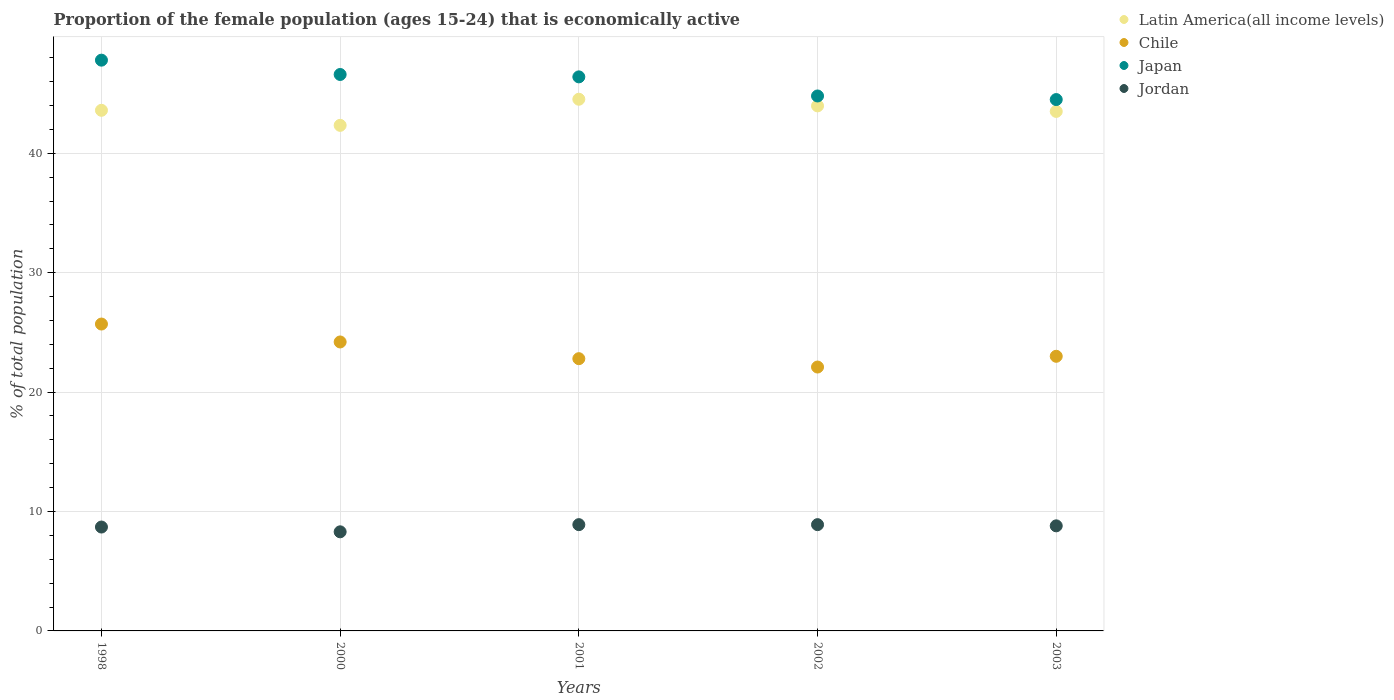How many different coloured dotlines are there?
Offer a very short reply. 4. Is the number of dotlines equal to the number of legend labels?
Make the answer very short. Yes. What is the proportion of the female population that is economically active in Latin America(all income levels) in 2002?
Offer a very short reply. 43.97. Across all years, what is the maximum proportion of the female population that is economically active in Latin America(all income levels)?
Your answer should be very brief. 44.53. Across all years, what is the minimum proportion of the female population that is economically active in Chile?
Your answer should be compact. 22.1. What is the total proportion of the female population that is economically active in Jordan in the graph?
Provide a short and direct response. 43.6. What is the difference between the proportion of the female population that is economically active in Japan in 1998 and that in 2000?
Offer a very short reply. 1.2. What is the difference between the proportion of the female population that is economically active in Japan in 2003 and the proportion of the female population that is economically active in Jordan in 2000?
Give a very brief answer. 36.2. What is the average proportion of the female population that is economically active in Japan per year?
Your response must be concise. 46.02. In the year 2001, what is the difference between the proportion of the female population that is economically active in Jordan and proportion of the female population that is economically active in Chile?
Your answer should be very brief. -13.9. What is the ratio of the proportion of the female population that is economically active in Latin America(all income levels) in 1998 to that in 2001?
Offer a very short reply. 0.98. Is the difference between the proportion of the female population that is economically active in Jordan in 1998 and 2003 greater than the difference between the proportion of the female population that is economically active in Chile in 1998 and 2003?
Offer a terse response. No. What is the difference between the highest and the second highest proportion of the female population that is economically active in Jordan?
Provide a short and direct response. 0. What is the difference between the highest and the lowest proportion of the female population that is economically active in Jordan?
Offer a very short reply. 0.6. In how many years, is the proportion of the female population that is economically active in Chile greater than the average proportion of the female population that is economically active in Chile taken over all years?
Offer a very short reply. 2. Is the sum of the proportion of the female population that is economically active in Chile in 2000 and 2003 greater than the maximum proportion of the female population that is economically active in Jordan across all years?
Your answer should be very brief. Yes. Does the proportion of the female population that is economically active in Japan monotonically increase over the years?
Your response must be concise. No. Is the proportion of the female population that is economically active in Latin America(all income levels) strictly greater than the proportion of the female population that is economically active in Chile over the years?
Make the answer very short. Yes. Is the proportion of the female population that is economically active in Jordan strictly less than the proportion of the female population that is economically active in Latin America(all income levels) over the years?
Offer a terse response. Yes. How many dotlines are there?
Offer a terse response. 4. What is the difference between two consecutive major ticks on the Y-axis?
Your answer should be very brief. 10. Are the values on the major ticks of Y-axis written in scientific E-notation?
Make the answer very short. No. Does the graph contain any zero values?
Provide a short and direct response. No. Where does the legend appear in the graph?
Provide a succinct answer. Top right. How many legend labels are there?
Your response must be concise. 4. How are the legend labels stacked?
Make the answer very short. Vertical. What is the title of the graph?
Provide a short and direct response. Proportion of the female population (ages 15-24) that is economically active. Does "Serbia" appear as one of the legend labels in the graph?
Your response must be concise. No. What is the label or title of the Y-axis?
Your answer should be compact. % of total population. What is the % of total population of Latin America(all income levels) in 1998?
Your response must be concise. 43.6. What is the % of total population of Chile in 1998?
Offer a very short reply. 25.7. What is the % of total population in Japan in 1998?
Provide a short and direct response. 47.8. What is the % of total population in Jordan in 1998?
Keep it short and to the point. 8.7. What is the % of total population of Latin America(all income levels) in 2000?
Give a very brief answer. 42.34. What is the % of total population in Chile in 2000?
Ensure brevity in your answer.  24.2. What is the % of total population in Japan in 2000?
Your answer should be very brief. 46.6. What is the % of total population of Jordan in 2000?
Keep it short and to the point. 8.3. What is the % of total population of Latin America(all income levels) in 2001?
Your answer should be very brief. 44.53. What is the % of total population in Chile in 2001?
Your answer should be very brief. 22.8. What is the % of total population of Japan in 2001?
Keep it short and to the point. 46.4. What is the % of total population of Jordan in 2001?
Make the answer very short. 8.9. What is the % of total population of Latin America(all income levels) in 2002?
Ensure brevity in your answer.  43.97. What is the % of total population of Chile in 2002?
Provide a short and direct response. 22.1. What is the % of total population of Japan in 2002?
Your answer should be compact. 44.8. What is the % of total population in Jordan in 2002?
Provide a short and direct response. 8.9. What is the % of total population of Latin America(all income levels) in 2003?
Your answer should be compact. 43.51. What is the % of total population of Japan in 2003?
Give a very brief answer. 44.5. What is the % of total population in Jordan in 2003?
Your answer should be very brief. 8.8. Across all years, what is the maximum % of total population of Latin America(all income levels)?
Make the answer very short. 44.53. Across all years, what is the maximum % of total population in Chile?
Ensure brevity in your answer.  25.7. Across all years, what is the maximum % of total population of Japan?
Ensure brevity in your answer.  47.8. Across all years, what is the maximum % of total population of Jordan?
Offer a terse response. 8.9. Across all years, what is the minimum % of total population of Latin America(all income levels)?
Provide a succinct answer. 42.34. Across all years, what is the minimum % of total population in Chile?
Keep it short and to the point. 22.1. Across all years, what is the minimum % of total population in Japan?
Give a very brief answer. 44.5. Across all years, what is the minimum % of total population in Jordan?
Offer a terse response. 8.3. What is the total % of total population of Latin America(all income levels) in the graph?
Provide a short and direct response. 217.95. What is the total % of total population of Chile in the graph?
Your answer should be compact. 117.8. What is the total % of total population of Japan in the graph?
Your response must be concise. 230.1. What is the total % of total population in Jordan in the graph?
Keep it short and to the point. 43.6. What is the difference between the % of total population of Latin America(all income levels) in 1998 and that in 2000?
Provide a succinct answer. 1.26. What is the difference between the % of total population in Jordan in 1998 and that in 2000?
Keep it short and to the point. 0.4. What is the difference between the % of total population in Latin America(all income levels) in 1998 and that in 2001?
Your answer should be compact. -0.93. What is the difference between the % of total population in Chile in 1998 and that in 2001?
Your answer should be very brief. 2.9. What is the difference between the % of total population in Japan in 1998 and that in 2001?
Your answer should be very brief. 1.4. What is the difference between the % of total population in Jordan in 1998 and that in 2001?
Your answer should be very brief. -0.2. What is the difference between the % of total population of Latin America(all income levels) in 1998 and that in 2002?
Your response must be concise. -0.37. What is the difference between the % of total population in Chile in 1998 and that in 2002?
Make the answer very short. 3.6. What is the difference between the % of total population in Japan in 1998 and that in 2002?
Provide a short and direct response. 3. What is the difference between the % of total population of Jordan in 1998 and that in 2002?
Make the answer very short. -0.2. What is the difference between the % of total population of Latin America(all income levels) in 1998 and that in 2003?
Make the answer very short. 0.09. What is the difference between the % of total population of Jordan in 1998 and that in 2003?
Provide a short and direct response. -0.1. What is the difference between the % of total population in Latin America(all income levels) in 2000 and that in 2001?
Offer a very short reply. -2.19. What is the difference between the % of total population in Chile in 2000 and that in 2001?
Provide a succinct answer. 1.4. What is the difference between the % of total population in Japan in 2000 and that in 2001?
Offer a terse response. 0.2. What is the difference between the % of total population of Latin America(all income levels) in 2000 and that in 2002?
Your answer should be very brief. -1.63. What is the difference between the % of total population in Latin America(all income levels) in 2000 and that in 2003?
Provide a succinct answer. -1.17. What is the difference between the % of total population in Chile in 2000 and that in 2003?
Offer a very short reply. 1.2. What is the difference between the % of total population in Japan in 2000 and that in 2003?
Make the answer very short. 2.1. What is the difference between the % of total population in Jordan in 2000 and that in 2003?
Give a very brief answer. -0.5. What is the difference between the % of total population of Latin America(all income levels) in 2001 and that in 2002?
Offer a very short reply. 0.56. What is the difference between the % of total population of Chile in 2001 and that in 2002?
Make the answer very short. 0.7. What is the difference between the % of total population of Japan in 2001 and that in 2002?
Offer a very short reply. 1.6. What is the difference between the % of total population in Latin America(all income levels) in 2001 and that in 2003?
Your answer should be compact. 1.02. What is the difference between the % of total population of Chile in 2001 and that in 2003?
Your response must be concise. -0.2. What is the difference between the % of total population of Japan in 2001 and that in 2003?
Provide a succinct answer. 1.9. What is the difference between the % of total population in Jordan in 2001 and that in 2003?
Offer a terse response. 0.1. What is the difference between the % of total population in Latin America(all income levels) in 2002 and that in 2003?
Ensure brevity in your answer.  0.46. What is the difference between the % of total population of Latin America(all income levels) in 1998 and the % of total population of Chile in 2000?
Offer a very short reply. 19.4. What is the difference between the % of total population of Latin America(all income levels) in 1998 and the % of total population of Japan in 2000?
Your response must be concise. -3. What is the difference between the % of total population of Latin America(all income levels) in 1998 and the % of total population of Jordan in 2000?
Provide a short and direct response. 35.3. What is the difference between the % of total population of Chile in 1998 and the % of total population of Japan in 2000?
Offer a very short reply. -20.9. What is the difference between the % of total population of Chile in 1998 and the % of total population of Jordan in 2000?
Make the answer very short. 17.4. What is the difference between the % of total population of Japan in 1998 and the % of total population of Jordan in 2000?
Provide a short and direct response. 39.5. What is the difference between the % of total population of Latin America(all income levels) in 1998 and the % of total population of Chile in 2001?
Ensure brevity in your answer.  20.8. What is the difference between the % of total population of Latin America(all income levels) in 1998 and the % of total population of Japan in 2001?
Your response must be concise. -2.8. What is the difference between the % of total population of Latin America(all income levels) in 1998 and the % of total population of Jordan in 2001?
Your response must be concise. 34.7. What is the difference between the % of total population of Chile in 1998 and the % of total population of Japan in 2001?
Ensure brevity in your answer.  -20.7. What is the difference between the % of total population of Chile in 1998 and the % of total population of Jordan in 2001?
Your answer should be compact. 16.8. What is the difference between the % of total population of Japan in 1998 and the % of total population of Jordan in 2001?
Offer a terse response. 38.9. What is the difference between the % of total population of Latin America(all income levels) in 1998 and the % of total population of Chile in 2002?
Offer a very short reply. 21.5. What is the difference between the % of total population in Latin America(all income levels) in 1998 and the % of total population in Japan in 2002?
Ensure brevity in your answer.  -1.2. What is the difference between the % of total population in Latin America(all income levels) in 1998 and the % of total population in Jordan in 2002?
Keep it short and to the point. 34.7. What is the difference between the % of total population in Chile in 1998 and the % of total population in Japan in 2002?
Your answer should be compact. -19.1. What is the difference between the % of total population in Japan in 1998 and the % of total population in Jordan in 2002?
Your answer should be very brief. 38.9. What is the difference between the % of total population in Latin America(all income levels) in 1998 and the % of total population in Chile in 2003?
Your answer should be compact. 20.6. What is the difference between the % of total population of Latin America(all income levels) in 1998 and the % of total population of Japan in 2003?
Offer a very short reply. -0.9. What is the difference between the % of total population in Latin America(all income levels) in 1998 and the % of total population in Jordan in 2003?
Your answer should be compact. 34.8. What is the difference between the % of total population in Chile in 1998 and the % of total population in Japan in 2003?
Ensure brevity in your answer.  -18.8. What is the difference between the % of total population of Japan in 1998 and the % of total population of Jordan in 2003?
Offer a very short reply. 39. What is the difference between the % of total population of Latin America(all income levels) in 2000 and the % of total population of Chile in 2001?
Your answer should be very brief. 19.54. What is the difference between the % of total population of Latin America(all income levels) in 2000 and the % of total population of Japan in 2001?
Keep it short and to the point. -4.06. What is the difference between the % of total population in Latin America(all income levels) in 2000 and the % of total population in Jordan in 2001?
Provide a succinct answer. 33.44. What is the difference between the % of total population in Chile in 2000 and the % of total population in Japan in 2001?
Provide a short and direct response. -22.2. What is the difference between the % of total population of Japan in 2000 and the % of total population of Jordan in 2001?
Give a very brief answer. 37.7. What is the difference between the % of total population of Latin America(all income levels) in 2000 and the % of total population of Chile in 2002?
Make the answer very short. 20.24. What is the difference between the % of total population in Latin America(all income levels) in 2000 and the % of total population in Japan in 2002?
Give a very brief answer. -2.46. What is the difference between the % of total population in Latin America(all income levels) in 2000 and the % of total population in Jordan in 2002?
Provide a succinct answer. 33.44. What is the difference between the % of total population in Chile in 2000 and the % of total population in Japan in 2002?
Your response must be concise. -20.6. What is the difference between the % of total population of Chile in 2000 and the % of total population of Jordan in 2002?
Provide a short and direct response. 15.3. What is the difference between the % of total population of Japan in 2000 and the % of total population of Jordan in 2002?
Your answer should be very brief. 37.7. What is the difference between the % of total population in Latin America(all income levels) in 2000 and the % of total population in Chile in 2003?
Keep it short and to the point. 19.34. What is the difference between the % of total population in Latin America(all income levels) in 2000 and the % of total population in Japan in 2003?
Your answer should be very brief. -2.16. What is the difference between the % of total population of Latin America(all income levels) in 2000 and the % of total population of Jordan in 2003?
Give a very brief answer. 33.54. What is the difference between the % of total population of Chile in 2000 and the % of total population of Japan in 2003?
Make the answer very short. -20.3. What is the difference between the % of total population in Japan in 2000 and the % of total population in Jordan in 2003?
Your answer should be very brief. 37.8. What is the difference between the % of total population of Latin America(all income levels) in 2001 and the % of total population of Chile in 2002?
Offer a very short reply. 22.43. What is the difference between the % of total population of Latin America(all income levels) in 2001 and the % of total population of Japan in 2002?
Your answer should be compact. -0.27. What is the difference between the % of total population of Latin America(all income levels) in 2001 and the % of total population of Jordan in 2002?
Your answer should be compact. 35.63. What is the difference between the % of total population of Japan in 2001 and the % of total population of Jordan in 2002?
Provide a succinct answer. 37.5. What is the difference between the % of total population of Latin America(all income levels) in 2001 and the % of total population of Chile in 2003?
Your response must be concise. 21.53. What is the difference between the % of total population in Latin America(all income levels) in 2001 and the % of total population in Japan in 2003?
Your answer should be compact. 0.03. What is the difference between the % of total population in Latin America(all income levels) in 2001 and the % of total population in Jordan in 2003?
Your answer should be compact. 35.73. What is the difference between the % of total population in Chile in 2001 and the % of total population in Japan in 2003?
Your response must be concise. -21.7. What is the difference between the % of total population in Japan in 2001 and the % of total population in Jordan in 2003?
Provide a succinct answer. 37.6. What is the difference between the % of total population of Latin America(all income levels) in 2002 and the % of total population of Chile in 2003?
Your answer should be very brief. 20.97. What is the difference between the % of total population in Latin America(all income levels) in 2002 and the % of total population in Japan in 2003?
Provide a succinct answer. -0.53. What is the difference between the % of total population of Latin America(all income levels) in 2002 and the % of total population of Jordan in 2003?
Your response must be concise. 35.17. What is the difference between the % of total population of Chile in 2002 and the % of total population of Japan in 2003?
Provide a short and direct response. -22.4. What is the difference between the % of total population of Chile in 2002 and the % of total population of Jordan in 2003?
Keep it short and to the point. 13.3. What is the difference between the % of total population in Japan in 2002 and the % of total population in Jordan in 2003?
Provide a succinct answer. 36. What is the average % of total population in Latin America(all income levels) per year?
Offer a very short reply. 43.59. What is the average % of total population in Chile per year?
Your response must be concise. 23.56. What is the average % of total population of Japan per year?
Offer a terse response. 46.02. What is the average % of total population of Jordan per year?
Your answer should be compact. 8.72. In the year 1998, what is the difference between the % of total population of Latin America(all income levels) and % of total population of Chile?
Your response must be concise. 17.9. In the year 1998, what is the difference between the % of total population in Latin America(all income levels) and % of total population in Japan?
Give a very brief answer. -4.2. In the year 1998, what is the difference between the % of total population in Latin America(all income levels) and % of total population in Jordan?
Keep it short and to the point. 34.9. In the year 1998, what is the difference between the % of total population in Chile and % of total population in Japan?
Give a very brief answer. -22.1. In the year 1998, what is the difference between the % of total population of Chile and % of total population of Jordan?
Give a very brief answer. 17. In the year 1998, what is the difference between the % of total population of Japan and % of total population of Jordan?
Make the answer very short. 39.1. In the year 2000, what is the difference between the % of total population of Latin America(all income levels) and % of total population of Chile?
Provide a short and direct response. 18.14. In the year 2000, what is the difference between the % of total population of Latin America(all income levels) and % of total population of Japan?
Your answer should be very brief. -4.26. In the year 2000, what is the difference between the % of total population in Latin America(all income levels) and % of total population in Jordan?
Your answer should be very brief. 34.04. In the year 2000, what is the difference between the % of total population of Chile and % of total population of Japan?
Ensure brevity in your answer.  -22.4. In the year 2000, what is the difference between the % of total population in Japan and % of total population in Jordan?
Your answer should be compact. 38.3. In the year 2001, what is the difference between the % of total population of Latin America(all income levels) and % of total population of Chile?
Your answer should be very brief. 21.73. In the year 2001, what is the difference between the % of total population of Latin America(all income levels) and % of total population of Japan?
Your response must be concise. -1.87. In the year 2001, what is the difference between the % of total population in Latin America(all income levels) and % of total population in Jordan?
Provide a short and direct response. 35.63. In the year 2001, what is the difference between the % of total population in Chile and % of total population in Japan?
Provide a succinct answer. -23.6. In the year 2001, what is the difference between the % of total population in Japan and % of total population in Jordan?
Keep it short and to the point. 37.5. In the year 2002, what is the difference between the % of total population of Latin America(all income levels) and % of total population of Chile?
Provide a succinct answer. 21.87. In the year 2002, what is the difference between the % of total population of Latin America(all income levels) and % of total population of Japan?
Offer a very short reply. -0.83. In the year 2002, what is the difference between the % of total population in Latin America(all income levels) and % of total population in Jordan?
Your response must be concise. 35.07. In the year 2002, what is the difference between the % of total population in Chile and % of total population in Japan?
Make the answer very short. -22.7. In the year 2002, what is the difference between the % of total population in Japan and % of total population in Jordan?
Offer a terse response. 35.9. In the year 2003, what is the difference between the % of total population of Latin America(all income levels) and % of total population of Chile?
Provide a succinct answer. 20.51. In the year 2003, what is the difference between the % of total population of Latin America(all income levels) and % of total population of Japan?
Your response must be concise. -0.99. In the year 2003, what is the difference between the % of total population of Latin America(all income levels) and % of total population of Jordan?
Provide a short and direct response. 34.71. In the year 2003, what is the difference between the % of total population of Chile and % of total population of Japan?
Give a very brief answer. -21.5. In the year 2003, what is the difference between the % of total population of Chile and % of total population of Jordan?
Your answer should be compact. 14.2. In the year 2003, what is the difference between the % of total population in Japan and % of total population in Jordan?
Your answer should be compact. 35.7. What is the ratio of the % of total population in Latin America(all income levels) in 1998 to that in 2000?
Provide a short and direct response. 1.03. What is the ratio of the % of total population in Chile in 1998 to that in 2000?
Offer a terse response. 1.06. What is the ratio of the % of total population in Japan in 1998 to that in 2000?
Provide a succinct answer. 1.03. What is the ratio of the % of total population in Jordan in 1998 to that in 2000?
Provide a succinct answer. 1.05. What is the ratio of the % of total population of Latin America(all income levels) in 1998 to that in 2001?
Give a very brief answer. 0.98. What is the ratio of the % of total population of Chile in 1998 to that in 2001?
Offer a terse response. 1.13. What is the ratio of the % of total population in Japan in 1998 to that in 2001?
Your answer should be compact. 1.03. What is the ratio of the % of total population of Jordan in 1998 to that in 2001?
Keep it short and to the point. 0.98. What is the ratio of the % of total population in Latin America(all income levels) in 1998 to that in 2002?
Your answer should be compact. 0.99. What is the ratio of the % of total population of Chile in 1998 to that in 2002?
Offer a terse response. 1.16. What is the ratio of the % of total population of Japan in 1998 to that in 2002?
Provide a succinct answer. 1.07. What is the ratio of the % of total population in Jordan in 1998 to that in 2002?
Provide a short and direct response. 0.98. What is the ratio of the % of total population in Latin America(all income levels) in 1998 to that in 2003?
Keep it short and to the point. 1. What is the ratio of the % of total population in Chile in 1998 to that in 2003?
Offer a terse response. 1.12. What is the ratio of the % of total population of Japan in 1998 to that in 2003?
Ensure brevity in your answer.  1.07. What is the ratio of the % of total population in Jordan in 1998 to that in 2003?
Provide a succinct answer. 0.99. What is the ratio of the % of total population in Latin America(all income levels) in 2000 to that in 2001?
Ensure brevity in your answer.  0.95. What is the ratio of the % of total population of Chile in 2000 to that in 2001?
Your answer should be compact. 1.06. What is the ratio of the % of total population in Jordan in 2000 to that in 2001?
Make the answer very short. 0.93. What is the ratio of the % of total population in Latin America(all income levels) in 2000 to that in 2002?
Provide a succinct answer. 0.96. What is the ratio of the % of total population of Chile in 2000 to that in 2002?
Provide a succinct answer. 1.09. What is the ratio of the % of total population in Japan in 2000 to that in 2002?
Make the answer very short. 1.04. What is the ratio of the % of total population in Jordan in 2000 to that in 2002?
Give a very brief answer. 0.93. What is the ratio of the % of total population of Latin America(all income levels) in 2000 to that in 2003?
Provide a succinct answer. 0.97. What is the ratio of the % of total population of Chile in 2000 to that in 2003?
Your answer should be very brief. 1.05. What is the ratio of the % of total population in Japan in 2000 to that in 2003?
Provide a short and direct response. 1.05. What is the ratio of the % of total population in Jordan in 2000 to that in 2003?
Offer a very short reply. 0.94. What is the ratio of the % of total population in Latin America(all income levels) in 2001 to that in 2002?
Ensure brevity in your answer.  1.01. What is the ratio of the % of total population of Chile in 2001 to that in 2002?
Offer a very short reply. 1.03. What is the ratio of the % of total population of Japan in 2001 to that in 2002?
Provide a short and direct response. 1.04. What is the ratio of the % of total population in Latin America(all income levels) in 2001 to that in 2003?
Your response must be concise. 1.02. What is the ratio of the % of total population in Chile in 2001 to that in 2003?
Your answer should be compact. 0.99. What is the ratio of the % of total population in Japan in 2001 to that in 2003?
Keep it short and to the point. 1.04. What is the ratio of the % of total population of Jordan in 2001 to that in 2003?
Your answer should be very brief. 1.01. What is the ratio of the % of total population in Latin America(all income levels) in 2002 to that in 2003?
Provide a succinct answer. 1.01. What is the ratio of the % of total population in Chile in 2002 to that in 2003?
Offer a very short reply. 0.96. What is the ratio of the % of total population in Japan in 2002 to that in 2003?
Your response must be concise. 1.01. What is the ratio of the % of total population of Jordan in 2002 to that in 2003?
Offer a terse response. 1.01. What is the difference between the highest and the second highest % of total population in Latin America(all income levels)?
Offer a very short reply. 0.56. What is the difference between the highest and the second highest % of total population in Japan?
Your response must be concise. 1.2. What is the difference between the highest and the lowest % of total population in Latin America(all income levels)?
Make the answer very short. 2.19. What is the difference between the highest and the lowest % of total population in Chile?
Ensure brevity in your answer.  3.6. What is the difference between the highest and the lowest % of total population in Japan?
Give a very brief answer. 3.3. What is the difference between the highest and the lowest % of total population of Jordan?
Give a very brief answer. 0.6. 